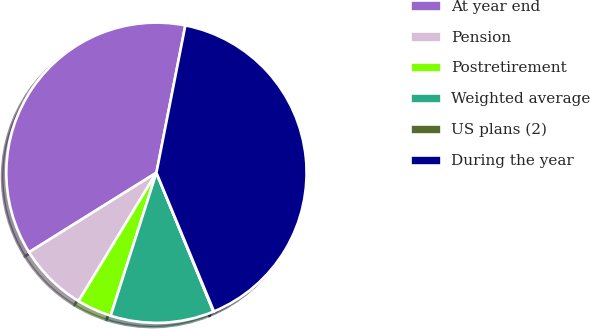Convert chart to OTSL. <chart><loc_0><loc_0><loc_500><loc_500><pie_chart><fcel>At year end<fcel>Pension<fcel>Postretirement<fcel>Weighted average<fcel>US plans (2)<fcel>During the year<nl><fcel>36.97%<fcel>7.44%<fcel>3.75%<fcel>11.13%<fcel>0.06%<fcel>40.66%<nl></chart> 